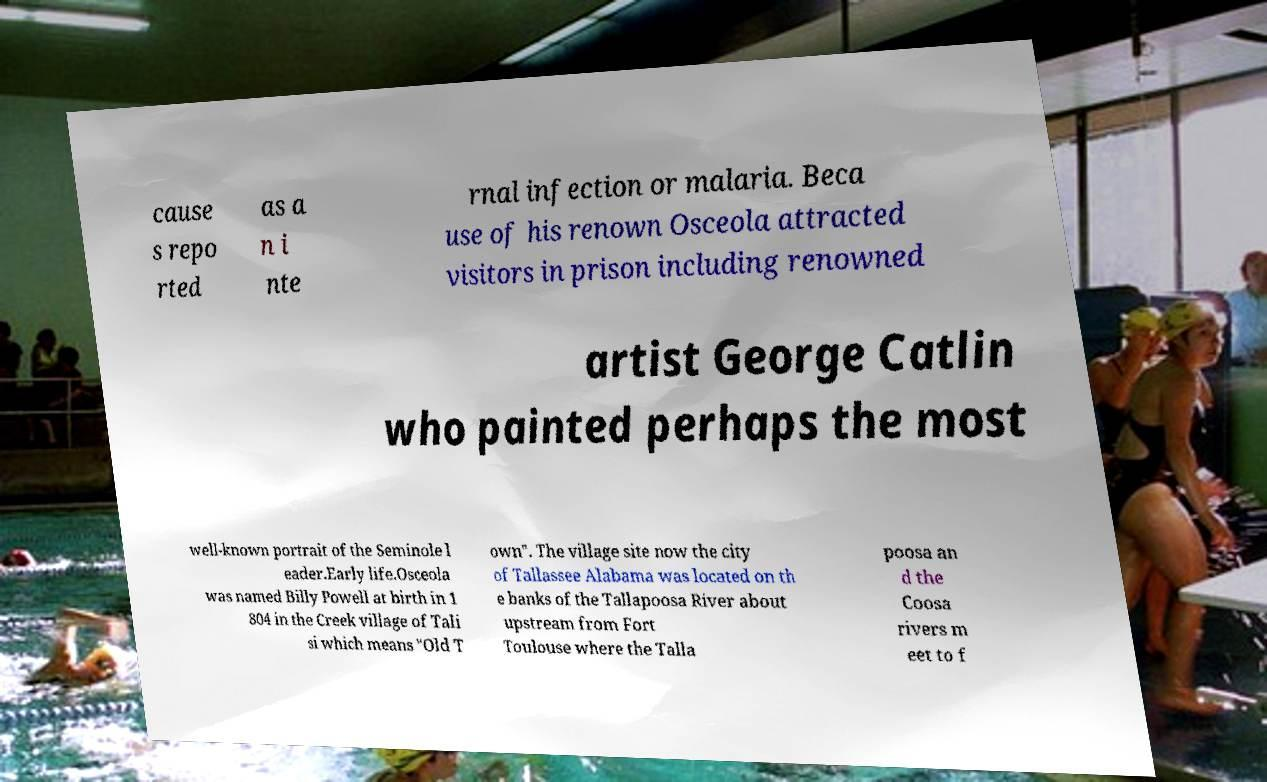I need the written content from this picture converted into text. Can you do that? cause s repo rted as a n i nte rnal infection or malaria. Beca use of his renown Osceola attracted visitors in prison including renowned artist George Catlin who painted perhaps the most well-known portrait of the Seminole l eader.Early life.Osceola was named Billy Powell at birth in 1 804 in the Creek village of Tali si which means "Old T own". The village site now the city of Tallassee Alabama was located on th e banks of the Tallapoosa River about upstream from Fort Toulouse where the Talla poosa an d the Coosa rivers m eet to f 